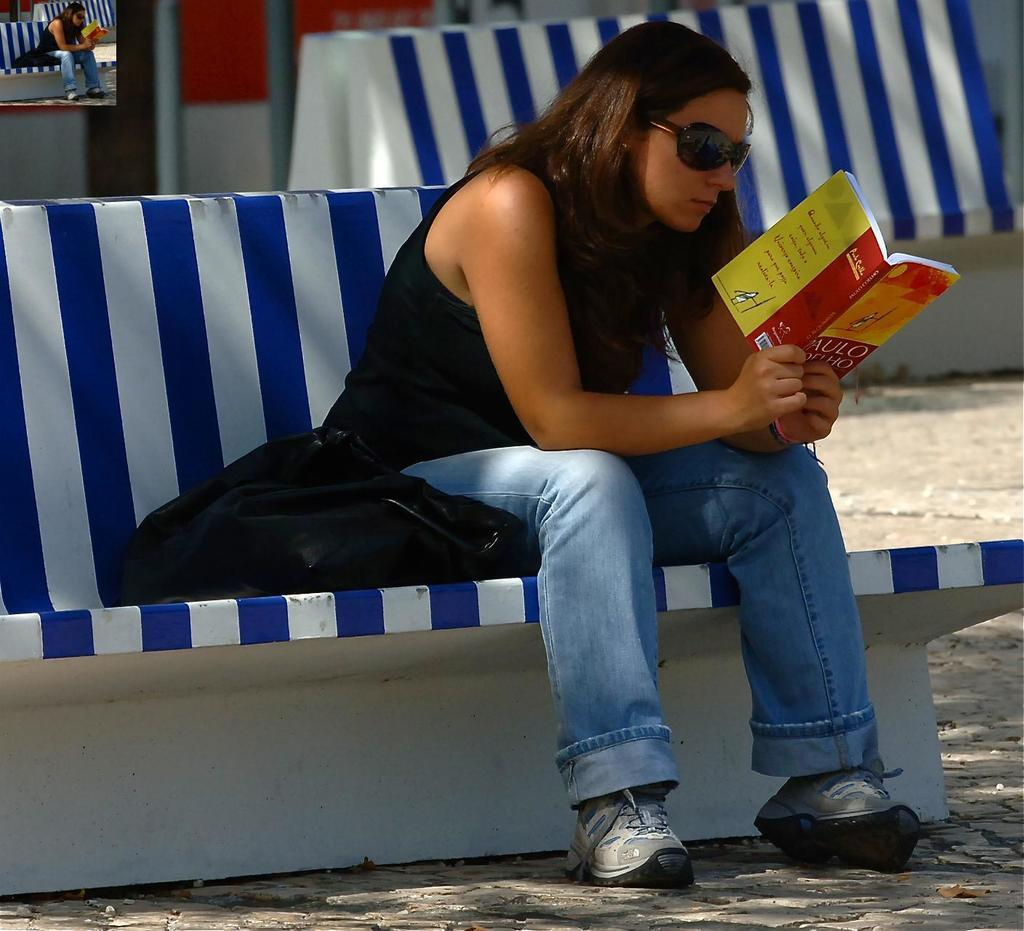<image>
Describe the image concisely. A woman is sitting on a blue and white, striped bench, reading a book written by Paulo Coelho. 